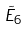<formula> <loc_0><loc_0><loc_500><loc_500>\tilde { E } _ { 6 }</formula> 